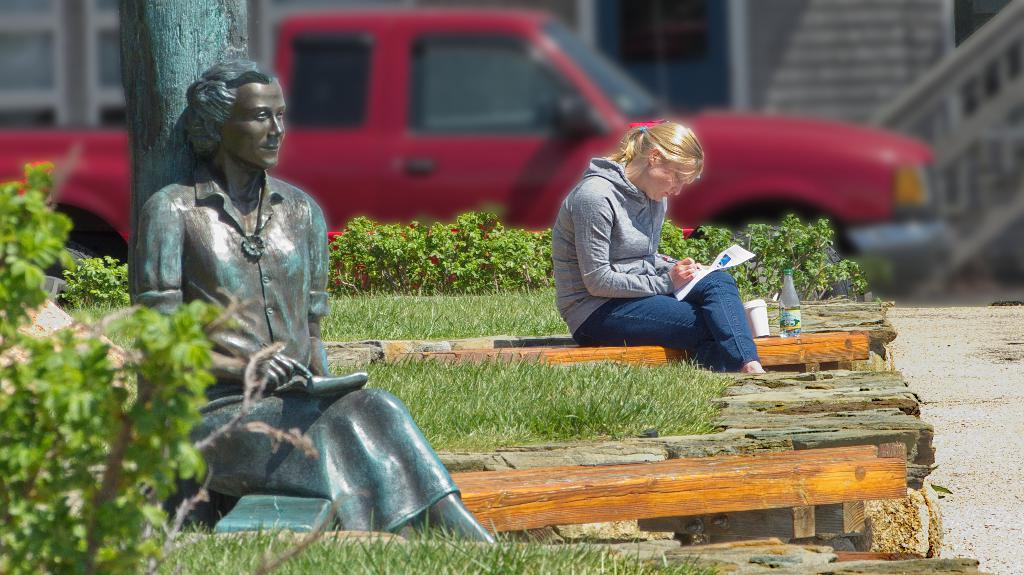What is the woman in the image doing? The woman is sitting and writing in the image. What can be seen to the left of the woman? There is a sculpture and a plant to the left of the woman. What is visible in the background of the image? There is a red car and a building in the background of the image. How many cords are connected to the butter in the image? There is no butter or cord present in the image. What type of lizards can be seen crawling on the plant in the image? There are no lizards present in the image; only a woman, a sculpture, a plant, a red car, and a building are visible. 